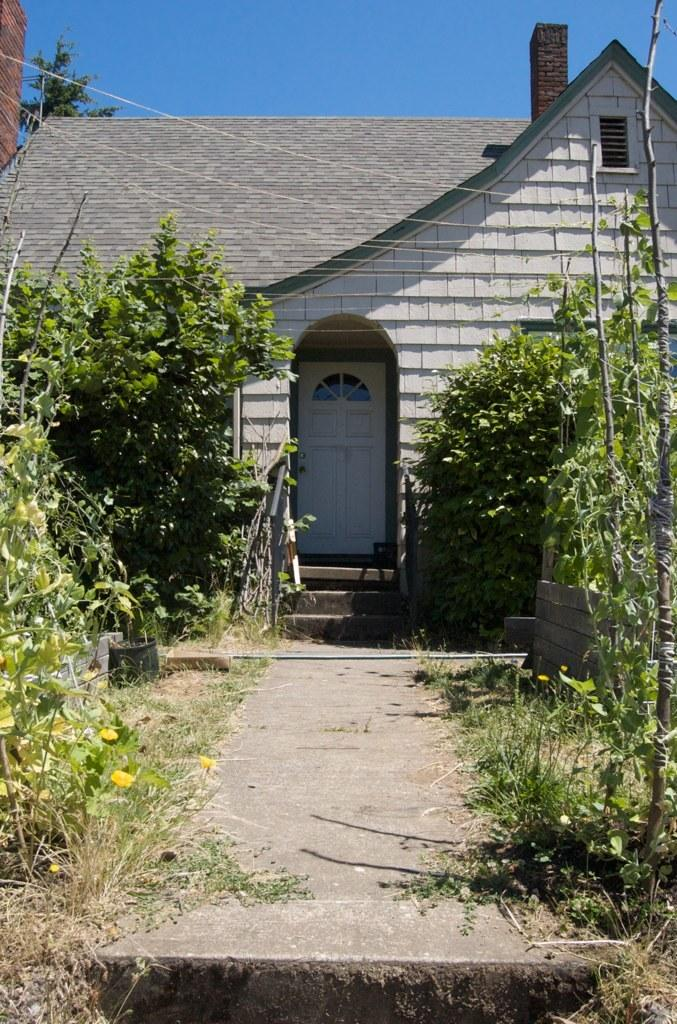What type of vegetation can be seen in the image? There are plants, trees, and flowers in the image. What type of structure is present in the image? There is a house in the image. What feature of the house is visible in the image? There is a door in the image. What can be seen in the background of the image? The sky is visible in the background of the image. Where is the kitten playing with the oven in the image? There is no kitten or oven present in the image. What is the end result of the plants growing in the image? The provided facts do not mention any end result or purpose for the plants in the image. 